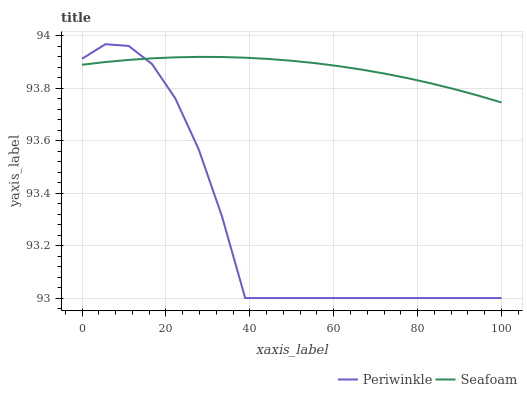Does Seafoam have the minimum area under the curve?
Answer yes or no. No. Is Seafoam the roughest?
Answer yes or no. No. Does Seafoam have the lowest value?
Answer yes or no. No. Does Seafoam have the highest value?
Answer yes or no. No. 